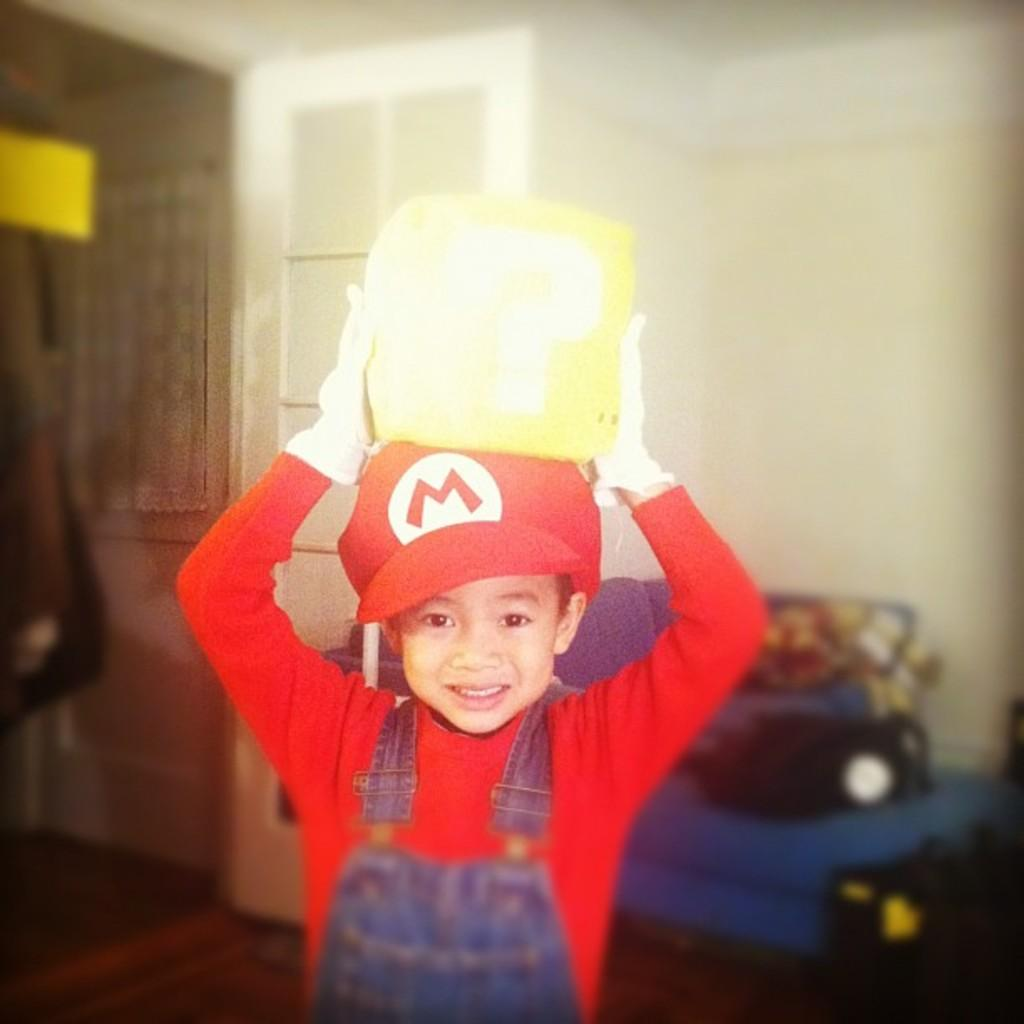What is the main subject of the image? The main subject of the image is a boy. Can you describe the boy's attire? The boy is wearing a cap. What is the boy holding on his head? The boy is holding something on his head, but the specific object cannot be identified from the image. How would you describe the background of the image? The background of the image is blurred. How many boys are riding the wheel in the image? There are no wheels or additional boys present in the image; it features only one boy wearing a cap and holding something on his head. Can you describe the monkey's interaction with the boy in the image? There are no monkeys present in the image; it features only the boy wearing a cap and holding something on his head. 